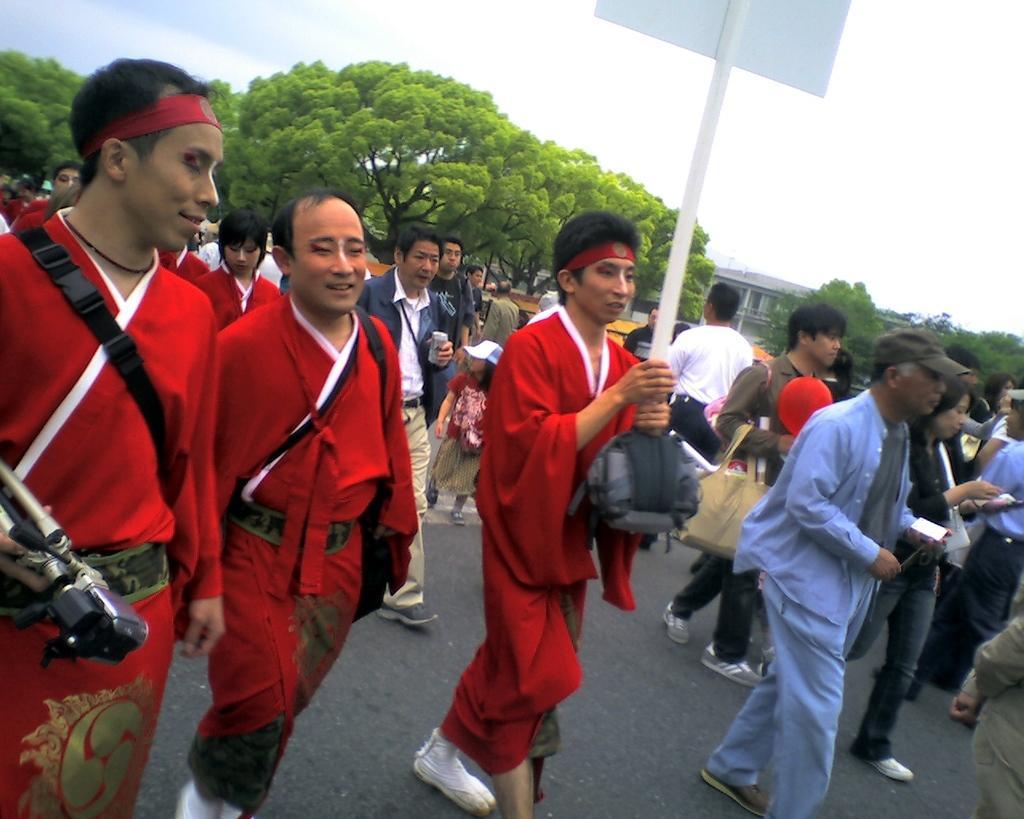Can you describe this image briefly? In this image, we can see a group of people on the road. Few people are holding some objects. In the middle of the image, we can see a person holding a pole with a board. In the background, we can see trees, building and the sky. 